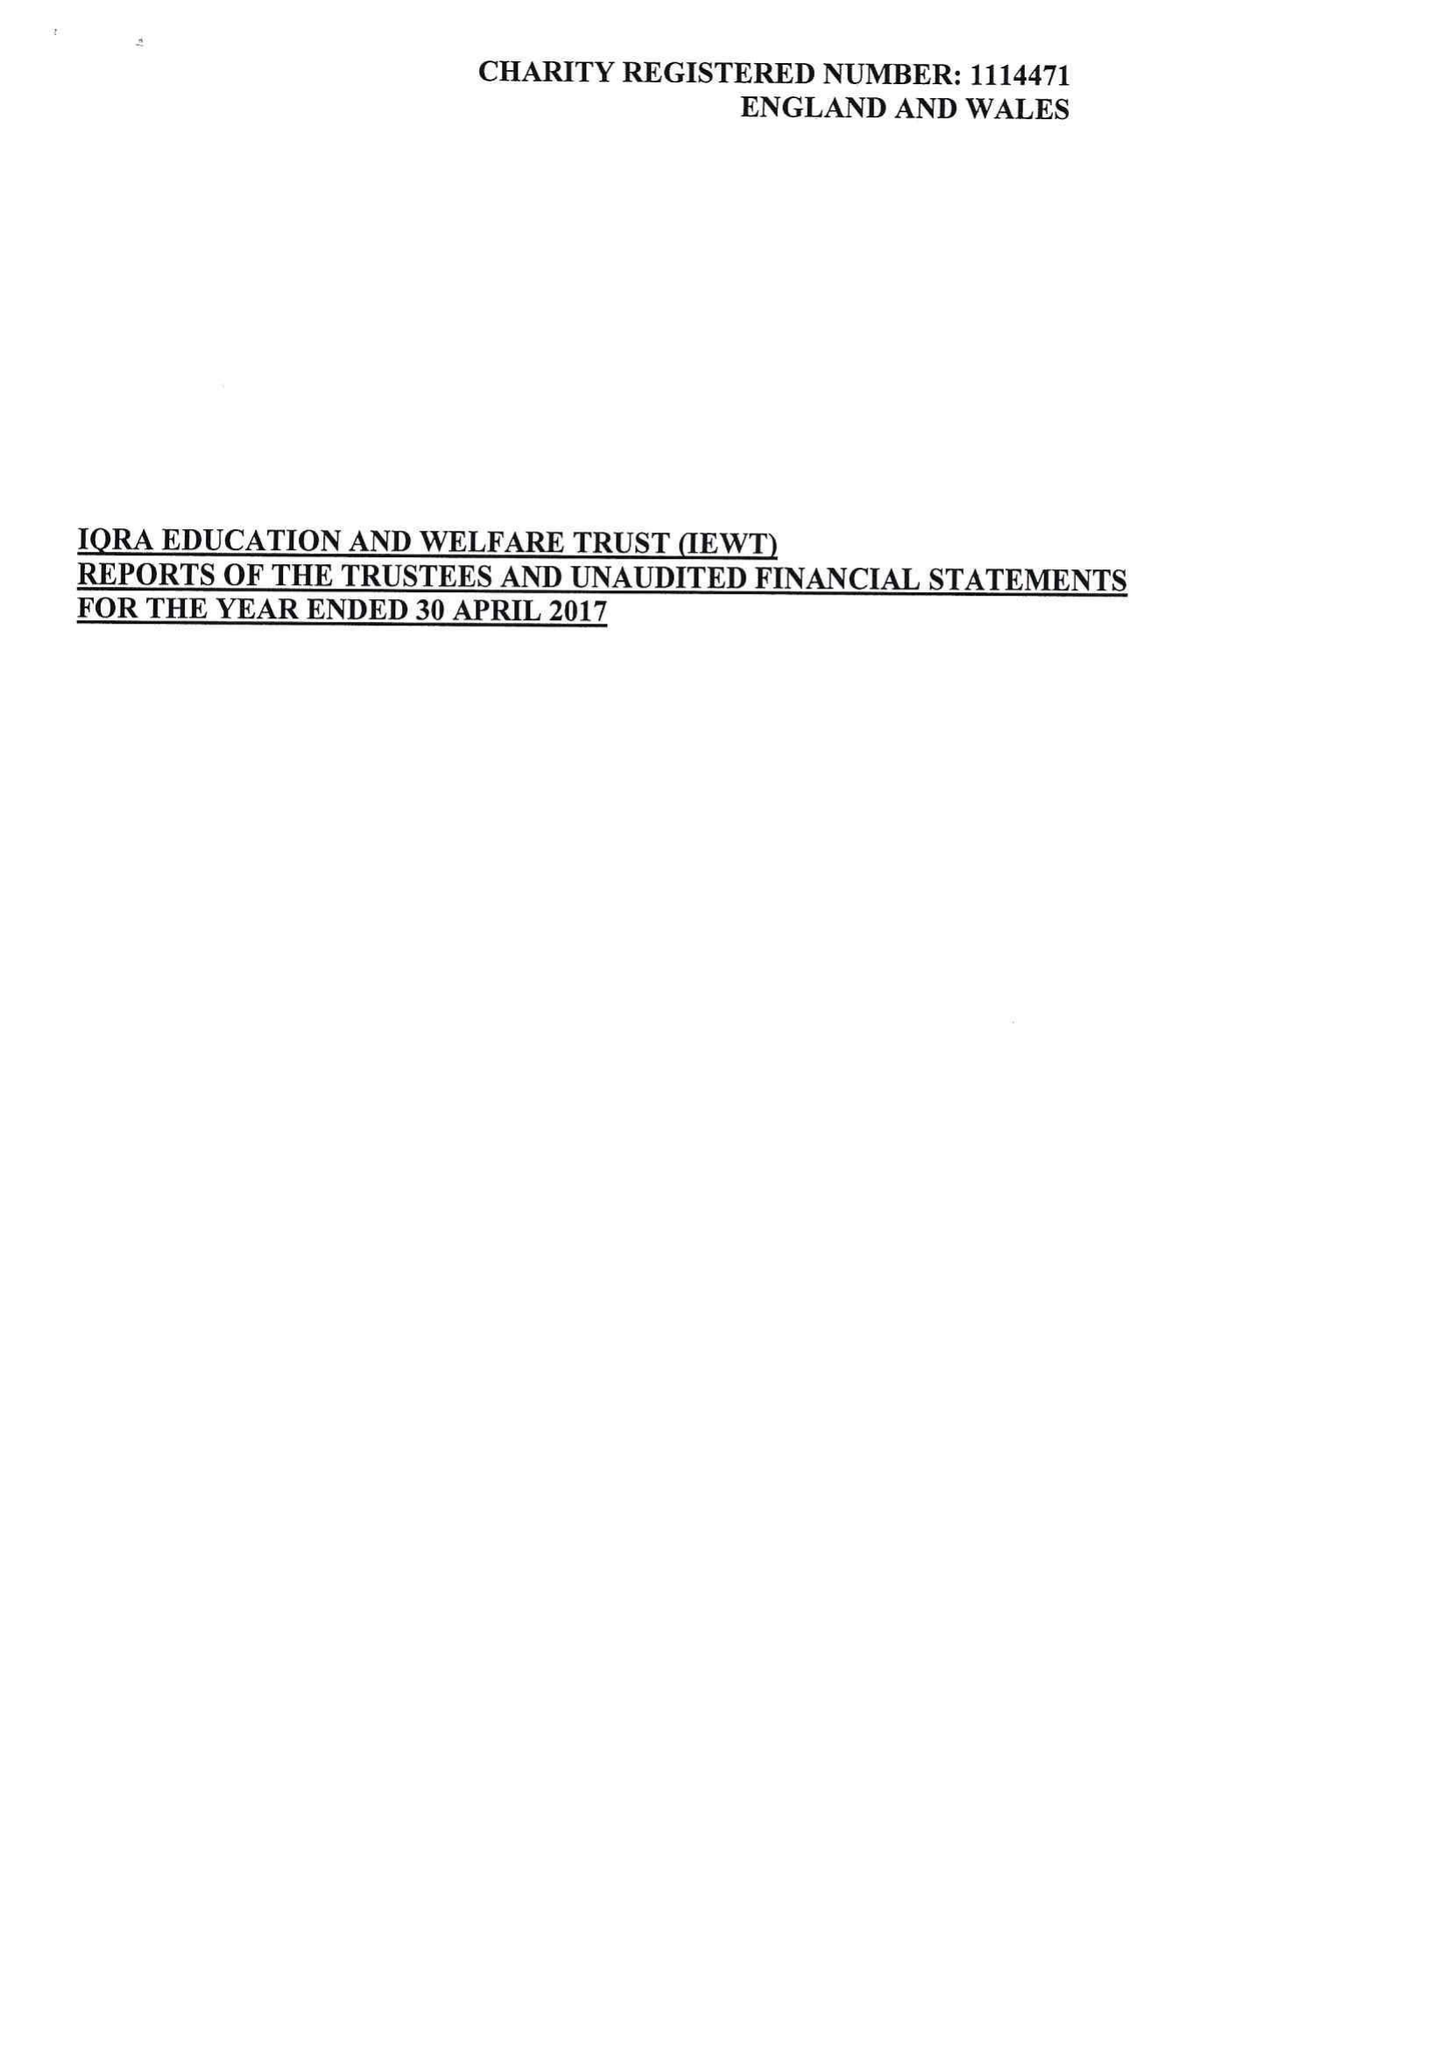What is the value for the income_annually_in_british_pounds?
Answer the question using a single word or phrase. 138856.00 